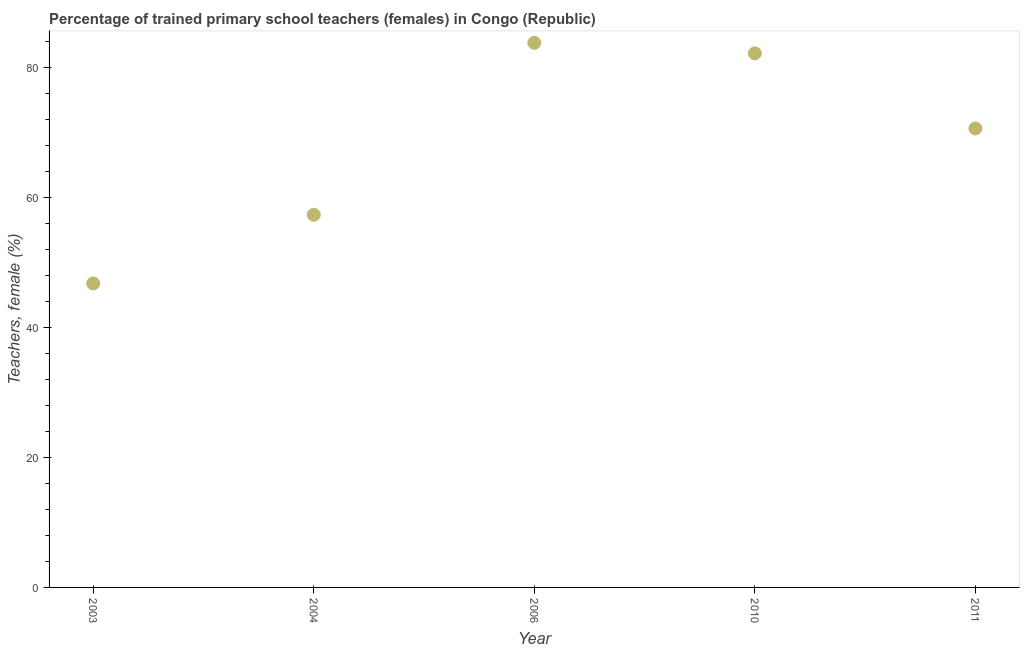What is the percentage of trained female teachers in 2006?
Your response must be concise. 83.86. Across all years, what is the maximum percentage of trained female teachers?
Offer a very short reply. 83.86. Across all years, what is the minimum percentage of trained female teachers?
Your response must be concise. 46.81. In which year was the percentage of trained female teachers maximum?
Your answer should be very brief. 2006. What is the sum of the percentage of trained female teachers?
Keep it short and to the point. 340.97. What is the difference between the percentage of trained female teachers in 2003 and 2010?
Provide a short and direct response. -35.43. What is the average percentage of trained female teachers per year?
Offer a very short reply. 68.19. What is the median percentage of trained female teachers?
Give a very brief answer. 70.68. What is the ratio of the percentage of trained female teachers in 2010 to that in 2011?
Offer a terse response. 1.16. What is the difference between the highest and the second highest percentage of trained female teachers?
Keep it short and to the point. 1.61. Is the sum of the percentage of trained female teachers in 2003 and 2004 greater than the maximum percentage of trained female teachers across all years?
Ensure brevity in your answer.  Yes. What is the difference between the highest and the lowest percentage of trained female teachers?
Provide a short and direct response. 37.04. Does the percentage of trained female teachers monotonically increase over the years?
Make the answer very short. No. How many dotlines are there?
Make the answer very short. 1. How many years are there in the graph?
Make the answer very short. 5. What is the difference between two consecutive major ticks on the Y-axis?
Ensure brevity in your answer.  20. Are the values on the major ticks of Y-axis written in scientific E-notation?
Provide a succinct answer. No. What is the title of the graph?
Keep it short and to the point. Percentage of trained primary school teachers (females) in Congo (Republic). What is the label or title of the Y-axis?
Offer a very short reply. Teachers, female (%). What is the Teachers, female (%) in 2003?
Provide a succinct answer. 46.81. What is the Teachers, female (%) in 2004?
Provide a succinct answer. 57.38. What is the Teachers, female (%) in 2006?
Your answer should be compact. 83.86. What is the Teachers, female (%) in 2010?
Your answer should be very brief. 82.24. What is the Teachers, female (%) in 2011?
Offer a terse response. 70.68. What is the difference between the Teachers, female (%) in 2003 and 2004?
Your answer should be very brief. -10.57. What is the difference between the Teachers, female (%) in 2003 and 2006?
Your answer should be very brief. -37.04. What is the difference between the Teachers, female (%) in 2003 and 2010?
Offer a very short reply. -35.43. What is the difference between the Teachers, female (%) in 2003 and 2011?
Your answer should be very brief. -23.86. What is the difference between the Teachers, female (%) in 2004 and 2006?
Your answer should be compact. -26.47. What is the difference between the Teachers, female (%) in 2004 and 2010?
Offer a very short reply. -24.86. What is the difference between the Teachers, female (%) in 2004 and 2011?
Make the answer very short. -13.29. What is the difference between the Teachers, female (%) in 2006 and 2010?
Offer a terse response. 1.61. What is the difference between the Teachers, female (%) in 2006 and 2011?
Give a very brief answer. 13.18. What is the difference between the Teachers, female (%) in 2010 and 2011?
Make the answer very short. 11.57. What is the ratio of the Teachers, female (%) in 2003 to that in 2004?
Give a very brief answer. 0.82. What is the ratio of the Teachers, female (%) in 2003 to that in 2006?
Keep it short and to the point. 0.56. What is the ratio of the Teachers, female (%) in 2003 to that in 2010?
Your answer should be very brief. 0.57. What is the ratio of the Teachers, female (%) in 2003 to that in 2011?
Your answer should be very brief. 0.66. What is the ratio of the Teachers, female (%) in 2004 to that in 2006?
Provide a succinct answer. 0.68. What is the ratio of the Teachers, female (%) in 2004 to that in 2010?
Your answer should be very brief. 0.7. What is the ratio of the Teachers, female (%) in 2004 to that in 2011?
Provide a succinct answer. 0.81. What is the ratio of the Teachers, female (%) in 2006 to that in 2011?
Your answer should be very brief. 1.19. What is the ratio of the Teachers, female (%) in 2010 to that in 2011?
Make the answer very short. 1.16. 